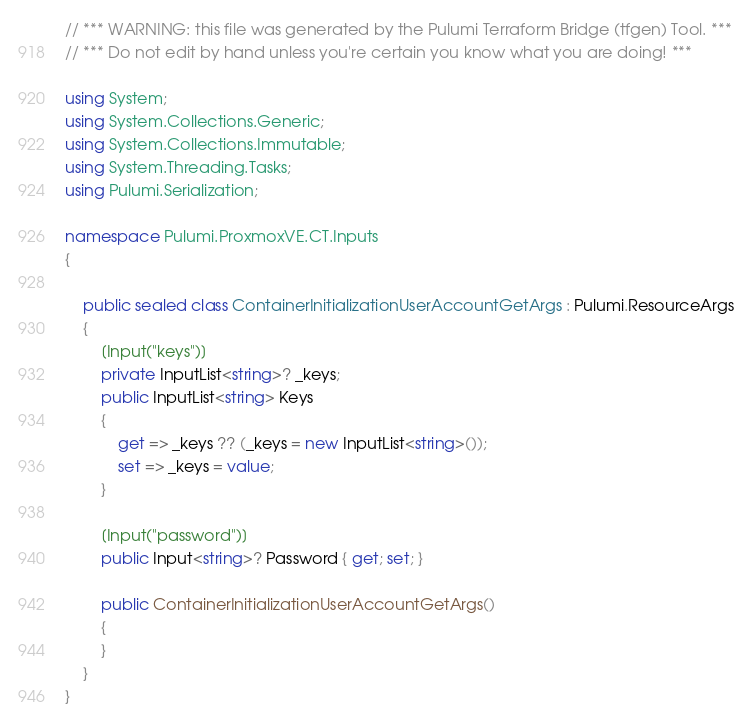Convert code to text. <code><loc_0><loc_0><loc_500><loc_500><_C#_>// *** WARNING: this file was generated by the Pulumi Terraform Bridge (tfgen) Tool. ***
// *** Do not edit by hand unless you're certain you know what you are doing! ***

using System;
using System.Collections.Generic;
using System.Collections.Immutable;
using System.Threading.Tasks;
using Pulumi.Serialization;

namespace Pulumi.ProxmoxVE.CT.Inputs
{

    public sealed class ContainerInitializationUserAccountGetArgs : Pulumi.ResourceArgs
    {
        [Input("keys")]
        private InputList<string>? _keys;
        public InputList<string> Keys
        {
            get => _keys ?? (_keys = new InputList<string>());
            set => _keys = value;
        }

        [Input("password")]
        public Input<string>? Password { get; set; }

        public ContainerInitializationUserAccountGetArgs()
        {
        }
    }
}
</code> 